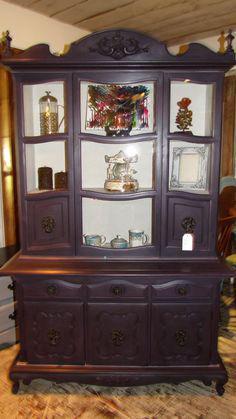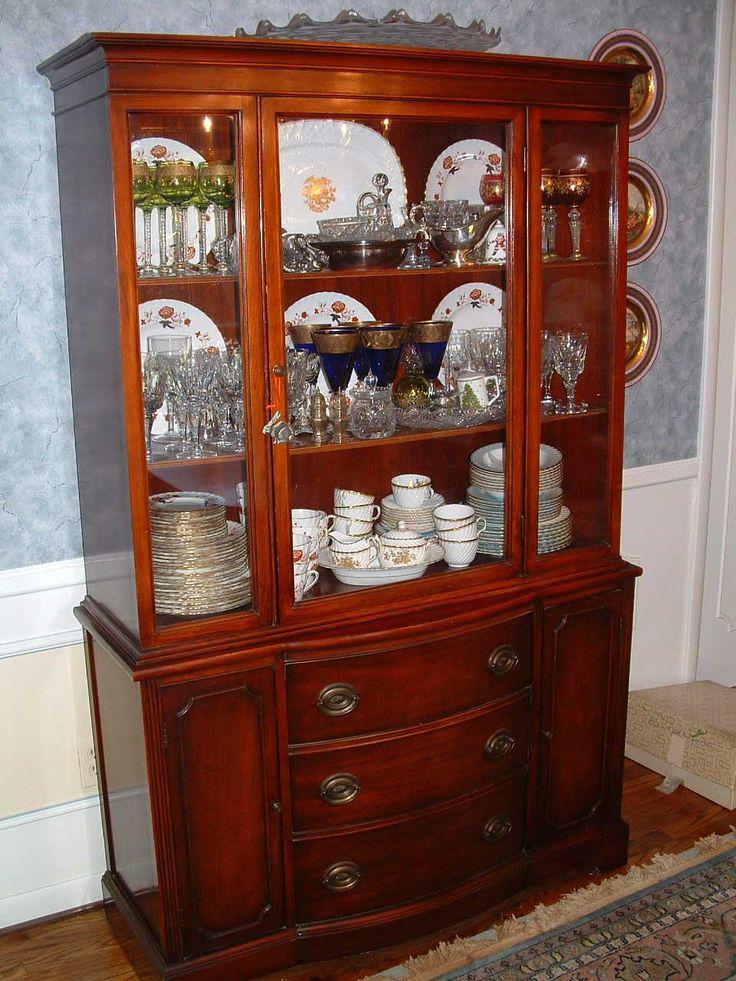The first image is the image on the left, the second image is the image on the right. Considering the images on both sides, is "A wooden hutch with three rows of dishes in its upper glass-paned section has three drawers between two doors in its lower section." valid? Answer yes or no. Yes. The first image is the image on the left, the second image is the image on the right. For the images shown, is this caption "The cabinet in the image on the right is set in the corner of a room." true? Answer yes or no. No. 